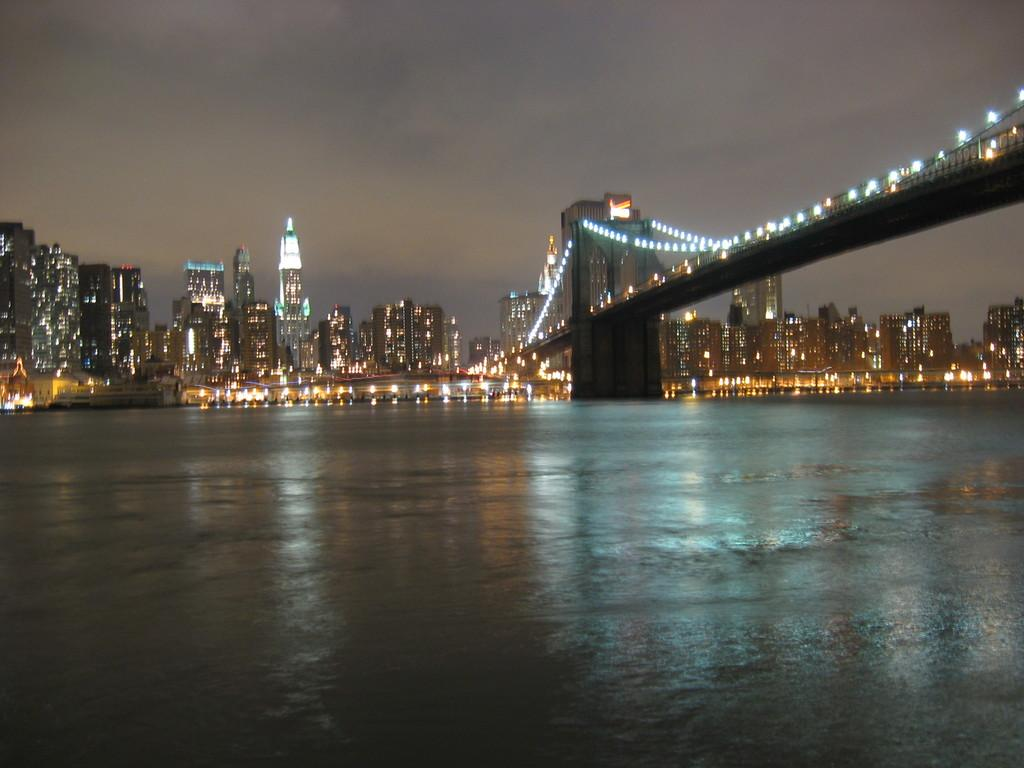What structure is located on the right side of the image? There is a bridge on the right side of the image. What is located beneath the bridge? There is a lake below the bridge. What can be seen in the background of the image? There are buildings in the background of the image. What feature do the buildings have? The buildings have lights. What is visible at the top of the image? The sky is visible in the image. What can be observed in the sky? There are clouds in the sky. What type of meat is being cooked on the bridge in the image? There is no meat or cooking activity present in the image; it features a bridge, a lake, buildings, and clouds in the sky. How many legs does the bridge have in the image? The bridge does not have legs; it is a structure that spans across the lake. 